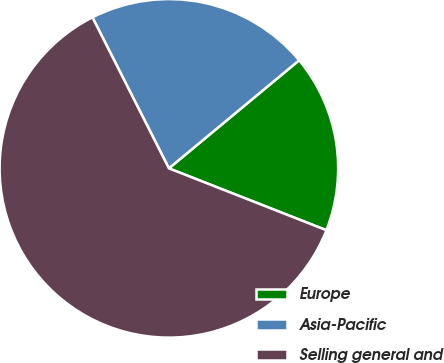<chart> <loc_0><loc_0><loc_500><loc_500><pie_chart><fcel>Europe<fcel>Asia-Pacific<fcel>Selling general and<nl><fcel>16.98%<fcel>21.44%<fcel>61.59%<nl></chart> 